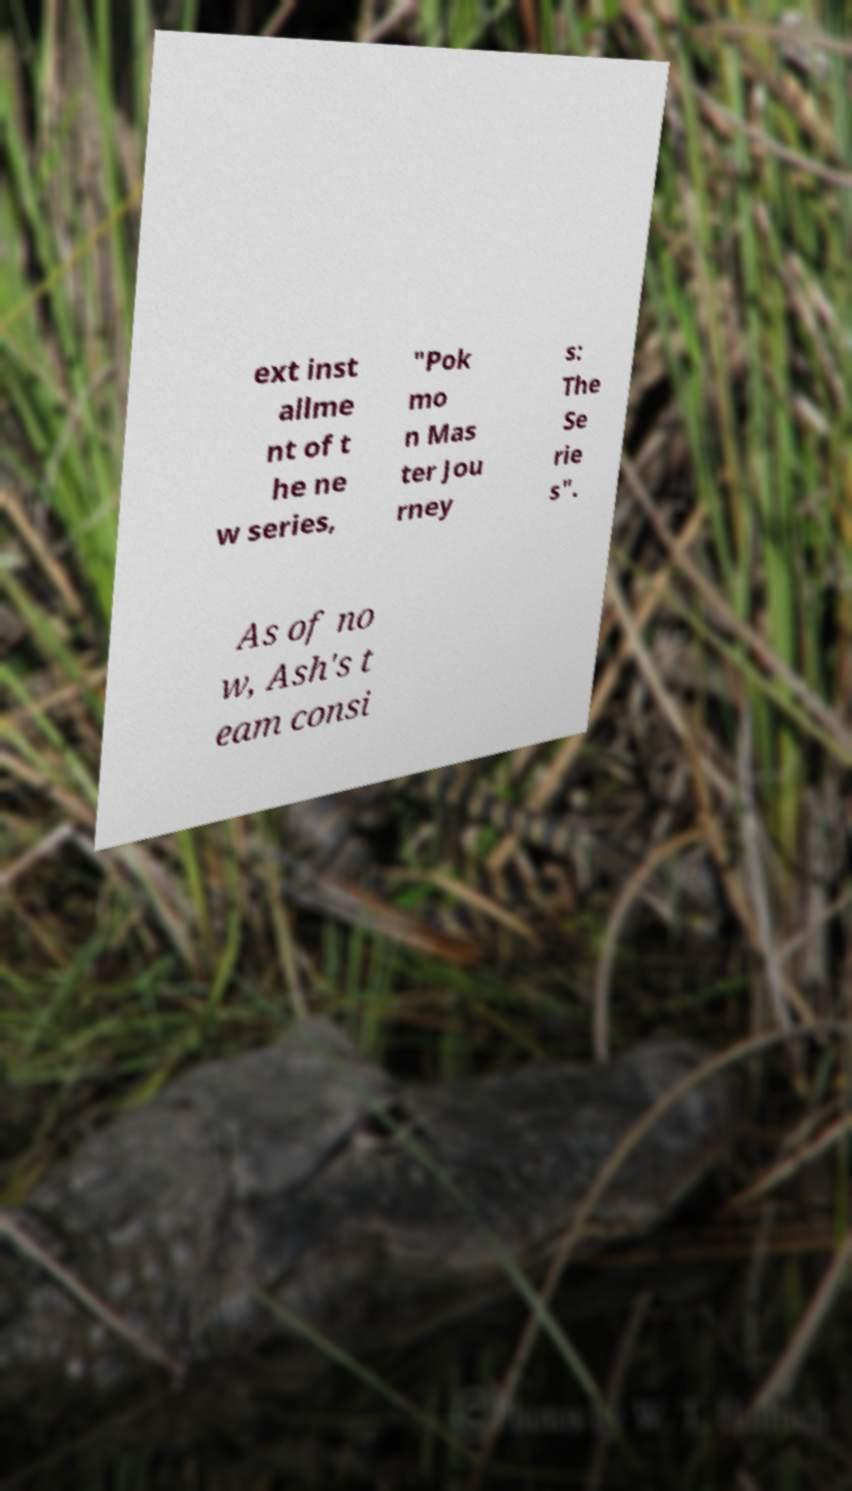Could you extract and type out the text from this image? ext inst allme nt of t he ne w series, "Pok mo n Mas ter Jou rney s: The Se rie s". As of no w, Ash's t eam consi 